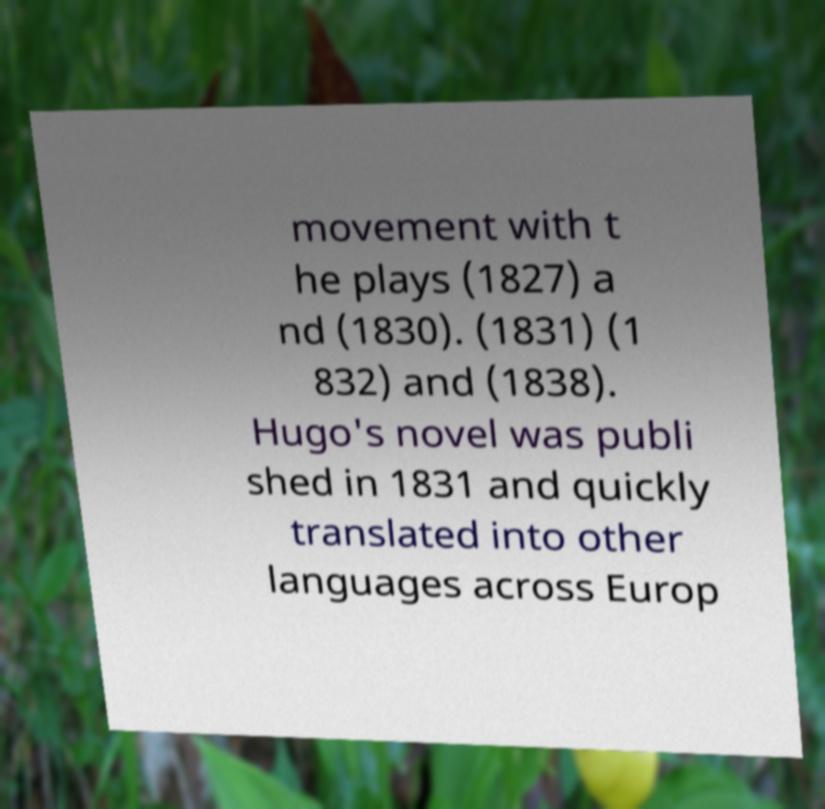Can you accurately transcribe the text from the provided image for me? movement with t he plays (1827) a nd (1830). (1831) (1 832) and (1838). Hugo's novel was publi shed in 1831 and quickly translated into other languages across Europ 